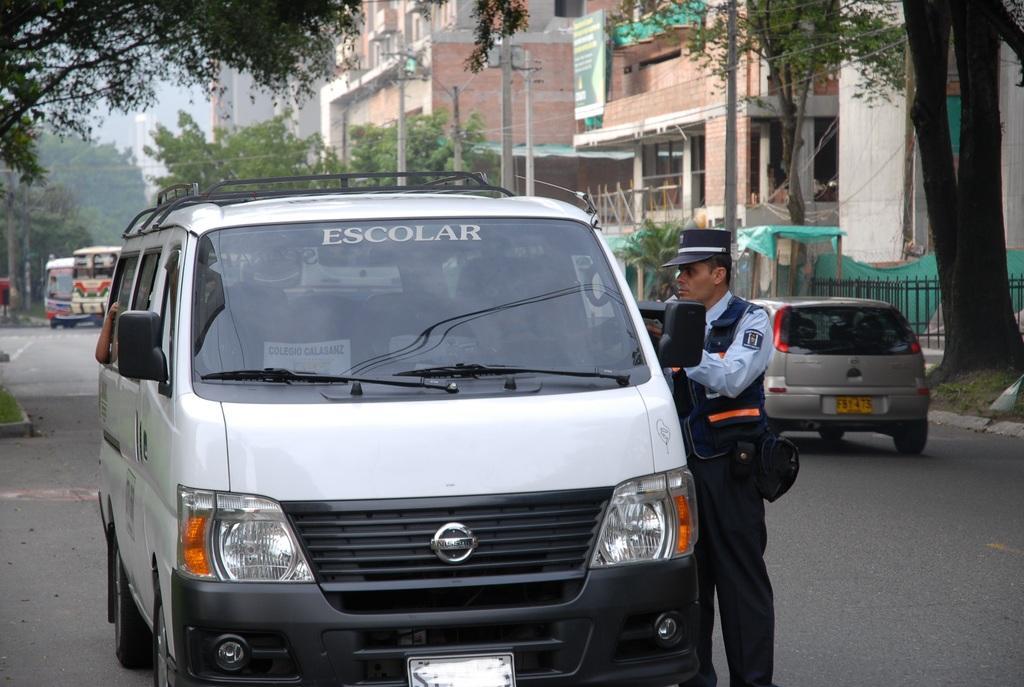Describe this image in one or two sentences. In this image I can see a road and number of vehicles. I can see a man in uniform standing next to a vehicle. In the background I can number of trees and number of buildings. 